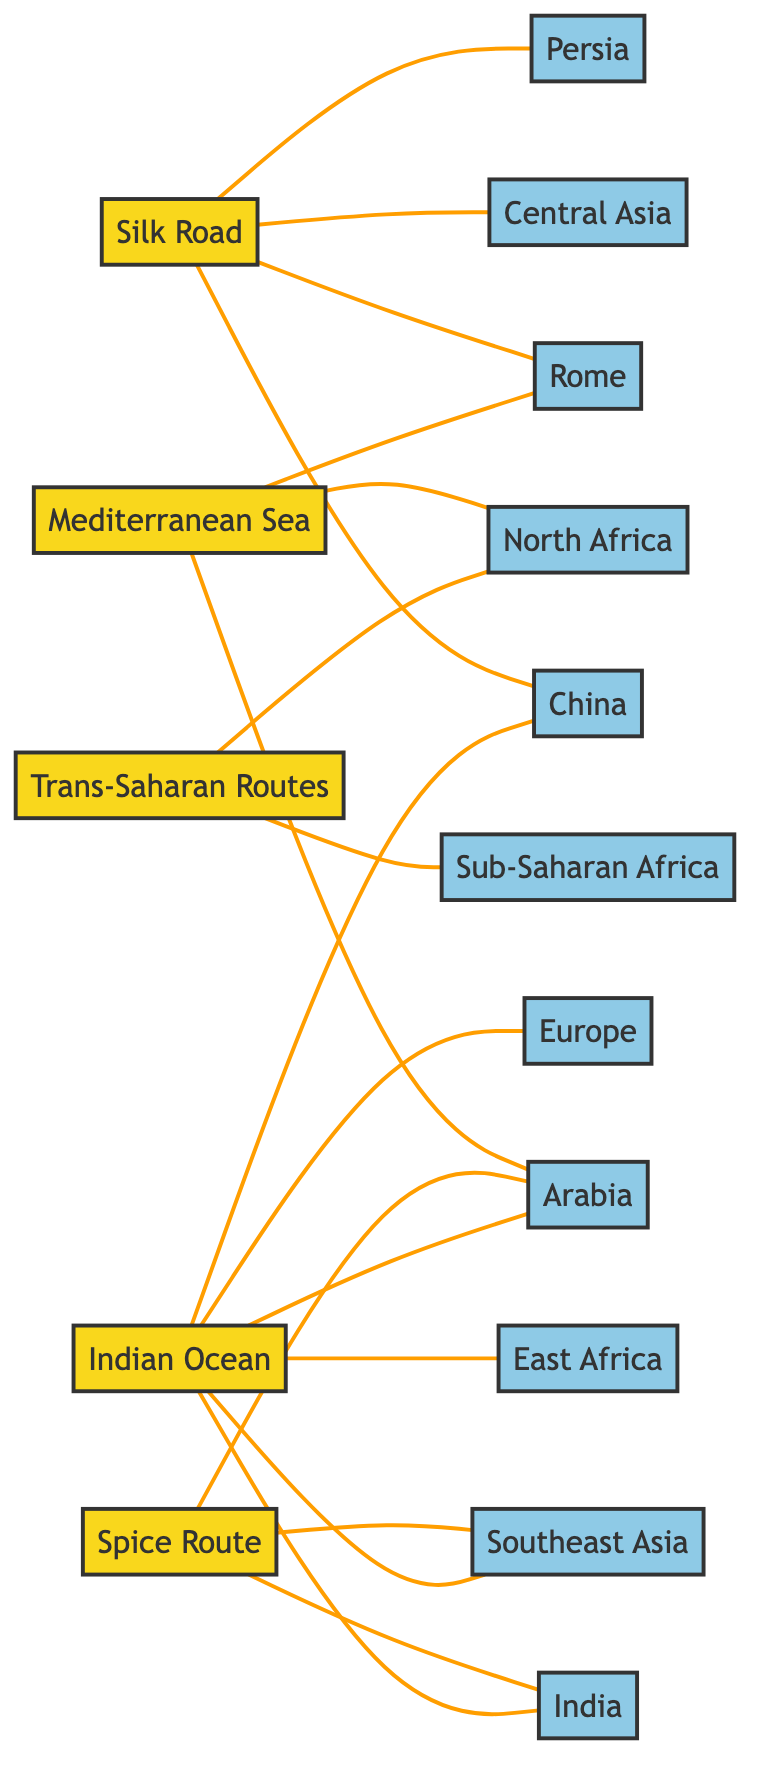What regions does the Silk Road connect? The Silk Road connects four regions: China, Rome, Central Asia, and Persia. By analyzing the links stemming from the Silk Road node in the diagram, we can see these connections clearly drawn as edges linking to each of these regions.
Answer: China, Rome, Central Asia, Persia How many trade routes are present in the diagram? There are five trade routes represented in the diagram: Silk Road, Mediterranean Sea, Trans-Saharan Routes, Spice Route, and Indian Ocean. Counting the nodes tagged as trade routes provides us with this total.
Answer: 5 Which region is connected to both the Spice Route and the Indian Ocean? The region that is connected to both the Spice Route and the Indian Ocean is Arabia. Tracing the links from both the Spice Route and Indian Ocean nodes, we find that Arabia is present in both connections.
Answer: Arabia What is the only trade route that connects to both North Africa and Sub-Saharan Africa? The only trade route connecting to both North Africa and Sub-Saharan Africa is the Trans-Saharan Routes. This can be deduced by examining the edges linked from the Trans-Saharan Routes node which show connections to both regions.
Answer: Trans-Saharan Routes Which region has the highest number of trade route connections? India has the highest number of trade route connections, linked to the Spice Route and Indian Ocean. By assessing the edges extending from the India node in the diagram, we can see connections to both of these trade routes, totaling two unique connections.
Answer: India How many total edges are connected to the Indian Ocean trade route? The Indian Ocean trade route has five edges connected to it: links to India, East Africa, Southeast Asia, Arabia, and China. By reviewing the connections from the Indian Ocean node, we can count these edges directly, arriving at the total of five.
Answer: 5 Which trade route connects to the highest number of regions? The Indian Ocean connects to the highest number of regions, which include India, East Africa, Southeast Asia, Arabia, China, and Europe—totalling six regions. By examining the direct connections from the Indian Ocean node, we confirm it links to six distinct areas.
Answer: Indian Ocean What region does the Mediterranean Sea not connect to? The Mediterranean Sea does not connect to Central Asia. Analyzing the links from the Mediterranean Sea node, we observe that it connects only to Rome, Arabia, and North Africa, but lacks connections to Central Asia.
Answer: Central Asia 